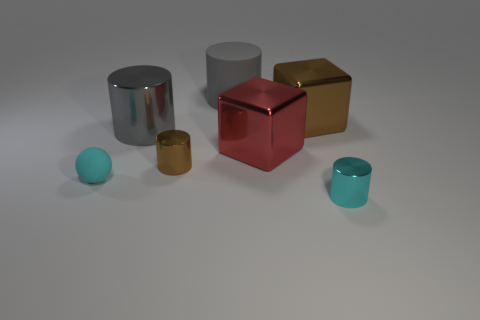What is the shape of the red shiny object that is the same size as the rubber cylinder?
Your answer should be very brief. Cube. How many small objects are either cyan metallic cylinders or cylinders?
Your response must be concise. 2. There is a gray thing in front of the matte thing that is right of the tiny rubber sphere; are there any small brown metal cylinders that are on the right side of it?
Your answer should be very brief. Yes. Are there any brown things of the same size as the brown cylinder?
Your answer should be compact. No. What is the material of the brown cylinder that is the same size as the matte ball?
Your answer should be very brief. Metal. There is a gray metallic cylinder; does it have the same size as the metal cylinder in front of the small sphere?
Provide a succinct answer. No. What number of metal objects are red cubes or tiny cyan objects?
Keep it short and to the point. 2. What number of small cyan metallic objects have the same shape as the gray metallic object?
Your response must be concise. 1. What is the material of the thing that is the same color as the large shiny cylinder?
Offer a very short reply. Rubber. Does the matte object that is behind the cyan matte object have the same size as the cyan object that is right of the big gray metal cylinder?
Offer a terse response. No. 